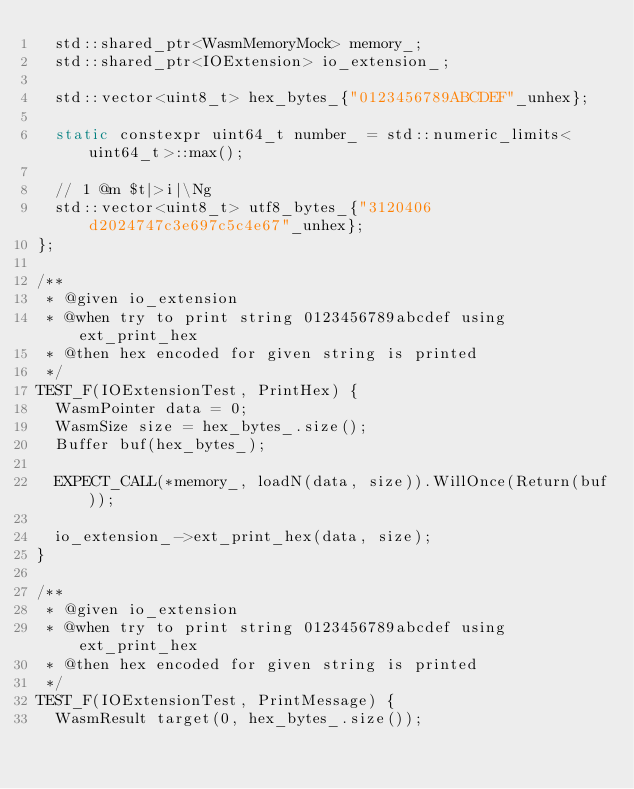Convert code to text. <code><loc_0><loc_0><loc_500><loc_500><_C++_>  std::shared_ptr<WasmMemoryMock> memory_;
  std::shared_ptr<IOExtension> io_extension_;

  std::vector<uint8_t> hex_bytes_{"0123456789ABCDEF"_unhex};

  static constexpr uint64_t number_ = std::numeric_limits<uint64_t>::max();

  // 1 @m $t|>i|\Ng
  std::vector<uint8_t> utf8_bytes_{"3120406d2024747c3e697c5c4e67"_unhex};
};

/**
 * @given io_extension
 * @when try to print string 0123456789abcdef using ext_print_hex
 * @then hex encoded for given string is printed
 */
TEST_F(IOExtensionTest, PrintHex) {
  WasmPointer data = 0;
  WasmSize size = hex_bytes_.size();
  Buffer buf(hex_bytes_);

  EXPECT_CALL(*memory_, loadN(data, size)).WillOnce(Return(buf));

  io_extension_->ext_print_hex(data, size);
}

/**
 * @given io_extension
 * @when try to print string 0123456789abcdef using ext_print_hex
 * @then hex encoded for given string is printed
 */
TEST_F(IOExtensionTest, PrintMessage) {
  WasmResult target(0, hex_bytes_.size());</code> 